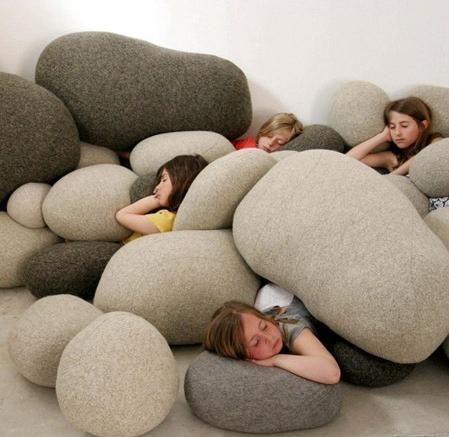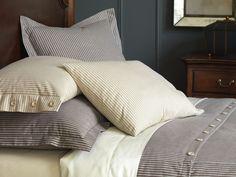The first image is the image on the left, the second image is the image on the right. Examine the images to the left and right. Is the description "An image includes at least one pillow shaped like a slice of bread." accurate? Answer yes or no. No. 